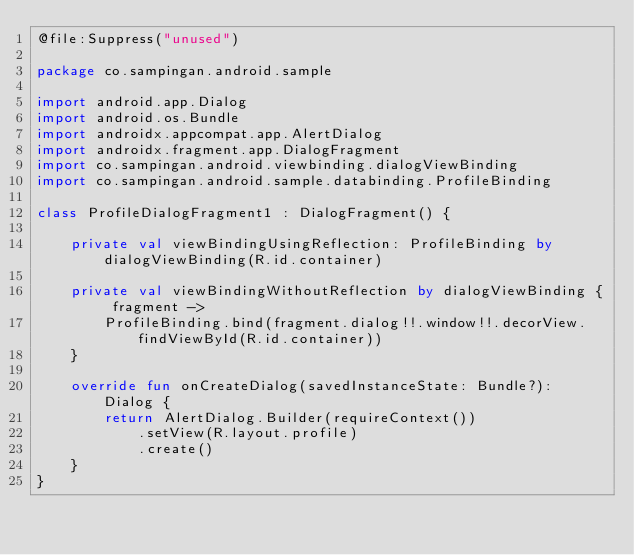Convert code to text. <code><loc_0><loc_0><loc_500><loc_500><_Kotlin_>@file:Suppress("unused")

package co.sampingan.android.sample

import android.app.Dialog
import android.os.Bundle
import androidx.appcompat.app.AlertDialog
import androidx.fragment.app.DialogFragment
import co.sampingan.android.viewbinding.dialogViewBinding
import co.sampingan.android.sample.databinding.ProfileBinding

class ProfileDialogFragment1 : DialogFragment() {

    private val viewBindingUsingReflection: ProfileBinding by dialogViewBinding(R.id.container)

    private val viewBindingWithoutReflection by dialogViewBinding { fragment ->
        ProfileBinding.bind(fragment.dialog!!.window!!.decorView.findViewById(R.id.container))
    }

    override fun onCreateDialog(savedInstanceState: Bundle?): Dialog {
        return AlertDialog.Builder(requireContext())
            .setView(R.layout.profile)
            .create()
    }
}
</code> 